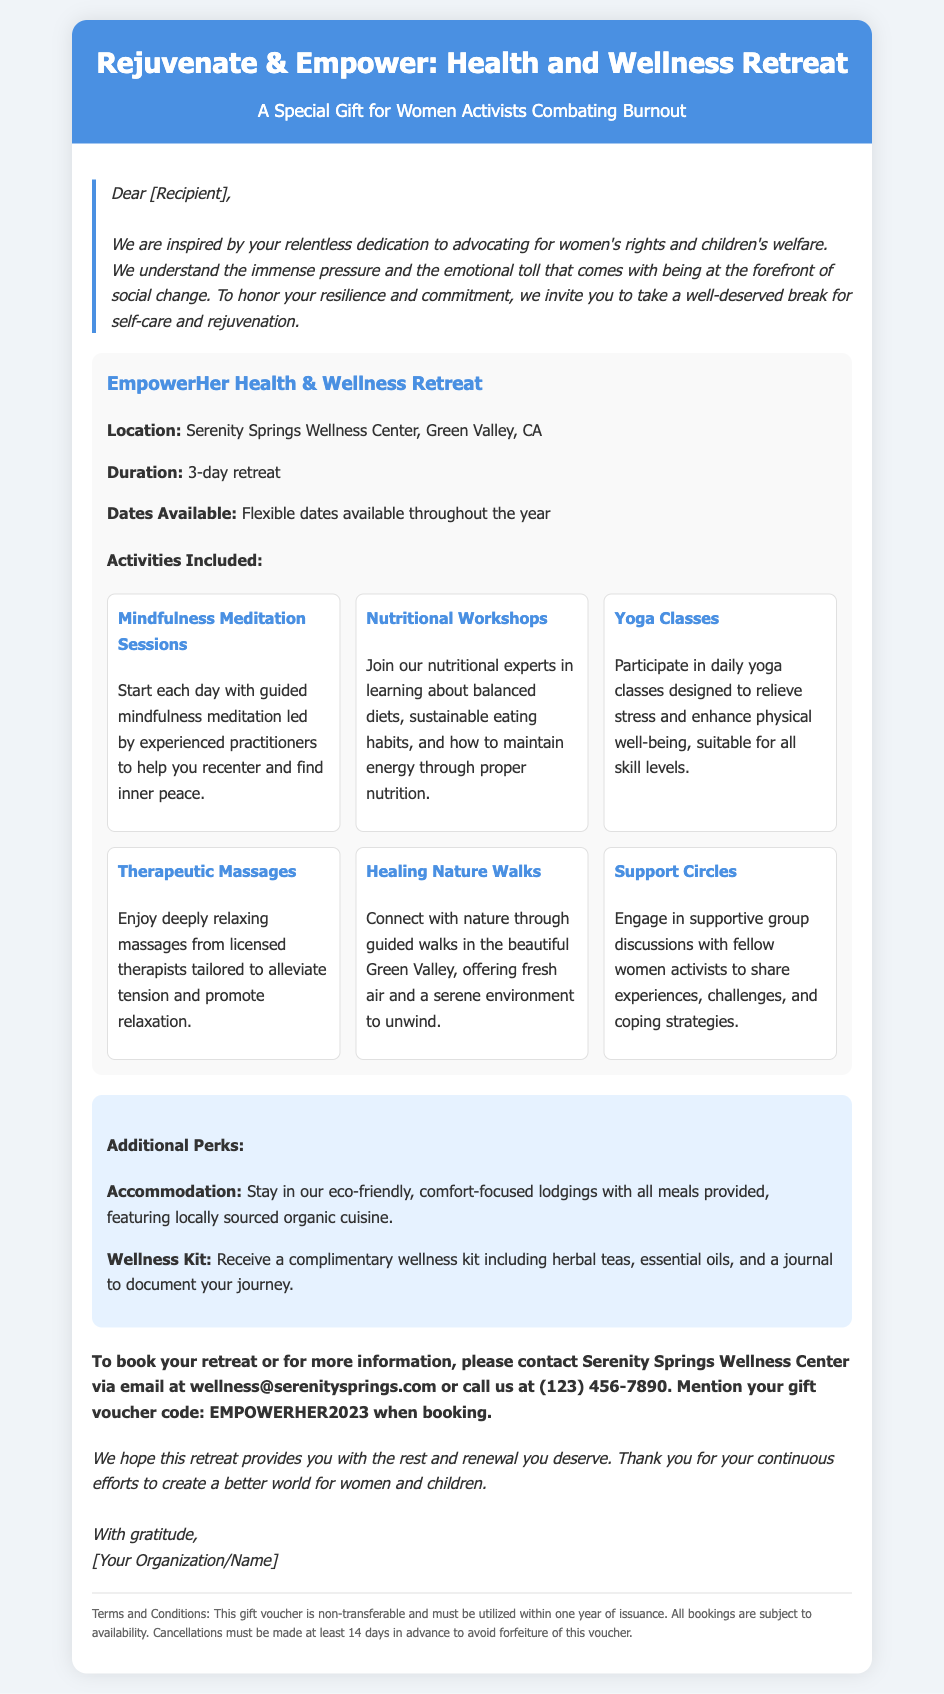What is the name of the retreat? The name of the retreat is stated in the header of the document.
Answer: EmpowerHer Health & Wellness Retreat Where is the retreat located? The location is mentioned in the offer details section of the document.
Answer: Serenity Springs Wellness Center, Green Valley, CA How long is the retreat? The duration of the retreat is specified in the offer details.
Answer: 3-day retreat What is the gift voucher code? The gift voucher code for bookings is provided in the contact section of the document.
Answer: EMPOWERHER2023 What additional benefit is included for participants? The additional perks are outlined in a specific section of the document.
Answer: Complimentary wellness kit What types of classes are included in the retreat activities? The types of activities offered are listed and categorized in the activities section.
Answer: Mindfulness Meditation Sessions, Nutritional Workshops, Yoga Classes, Therapeutic Massages, Healing Nature Walks, Support Circles What is required for cancellation of the booking? The cancellation requirement is stated in the fine print section of the document.
Answer: Cancel at least 14 days in advance How can one contact the wellness center for booking? The document provides contact details for the wellness center under the redeem section.
Answer: Email at wellness@serenitysprings.com or call (123) 456-7890 